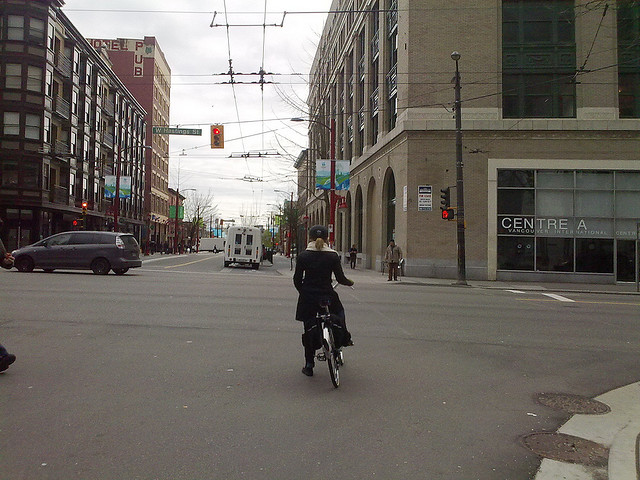What could the cyclist be headed towards? The cyclist might be headed towards a nearby park, perhaps to enjoy a leisurely ride. Alternatively, she could be commuting to work, shopping, or meeting friends at a café further down the street. The destination is open to imagination given the urban setting. Imagine she discovers a hidden alleyway leading to a secret garden. Describe it in detail. As she turns a corner, she notices a narrow, cobblestone alleyway partially hidden behind tall buildings. Curiosity piqued, she maneuvers her bike down the alley and stumbles upon an enchanting secret garden. It is an oasis of greenery with lush plants, colorful flowers in full bloom, and intricately designed stone pathways winding through the space. Birdsong fills the air, and a small, serene pond sits at the center, reflecting the beauty around it. The garden is a tranquil escape from the city's hustle, with benches placed thoughtfully for visitors to sit and soak in the natural splendor. 